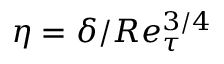<formula> <loc_0><loc_0><loc_500><loc_500>\eta = \delta / R e _ { \tau } ^ { 3 / 4 }</formula> 